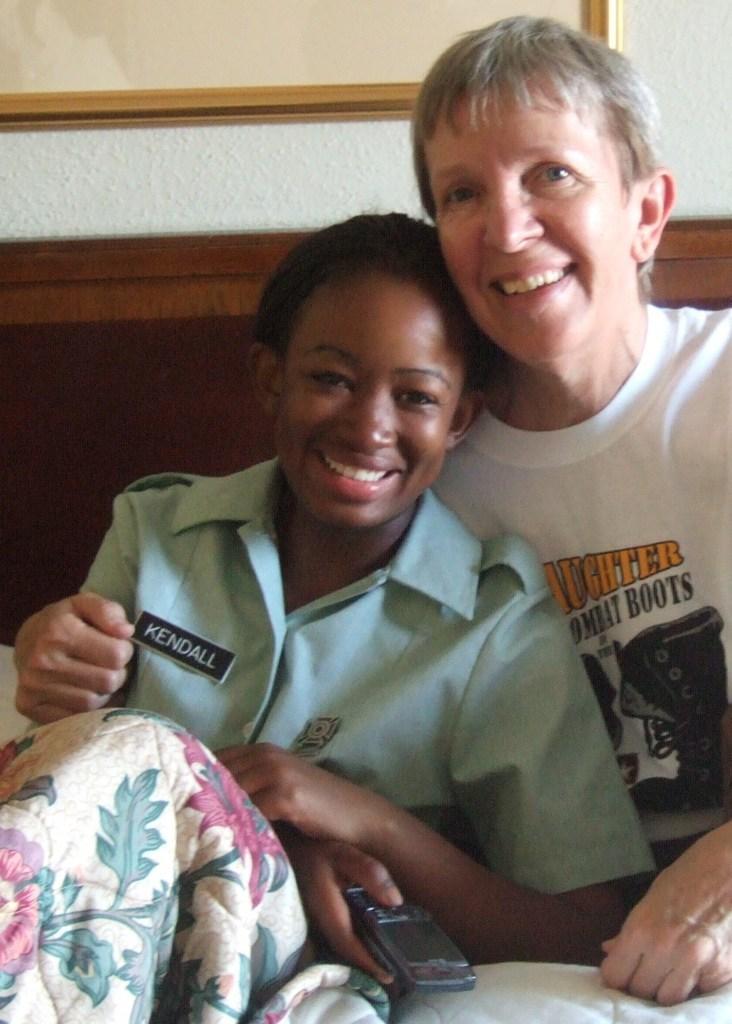Describe this image in one or two sentences. In the picture there is a woman and a child present, behind them there is a wall. 